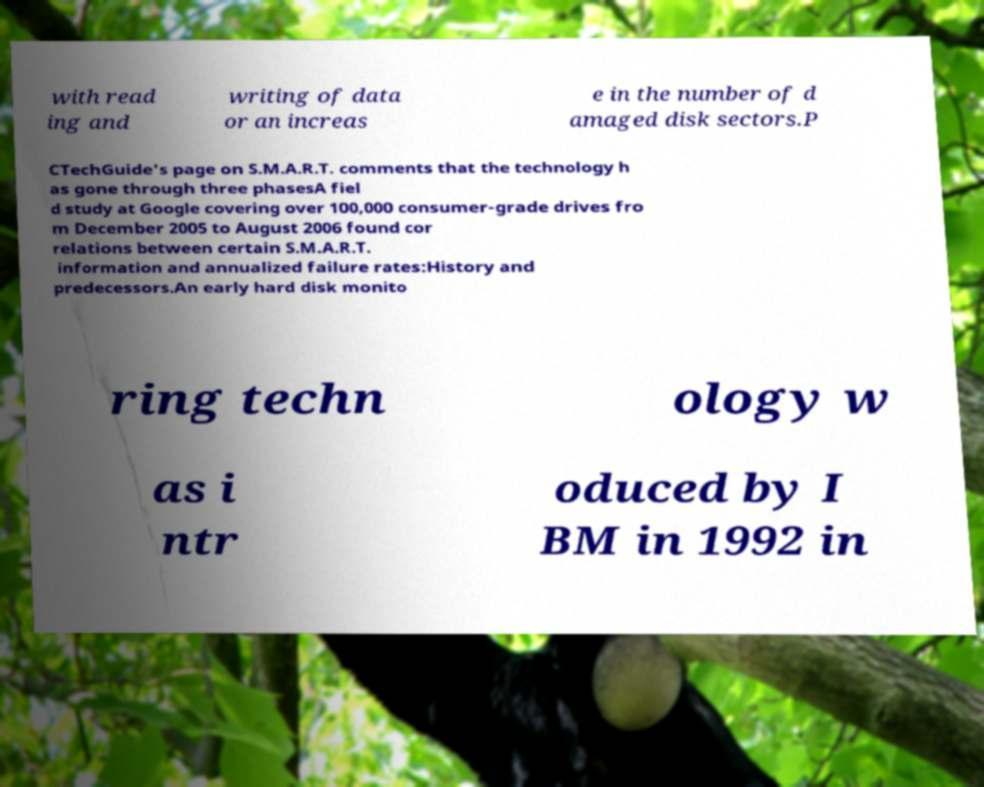Can you read and provide the text displayed in the image?This photo seems to have some interesting text. Can you extract and type it out for me? with read ing and writing of data or an increas e in the number of d amaged disk sectors.P CTechGuide's page on S.M.A.R.T. comments that the technology h as gone through three phasesA fiel d study at Google covering over 100,000 consumer-grade drives fro m December 2005 to August 2006 found cor relations between certain S.M.A.R.T. information and annualized failure rates:History and predecessors.An early hard disk monito ring techn ology w as i ntr oduced by I BM in 1992 in 